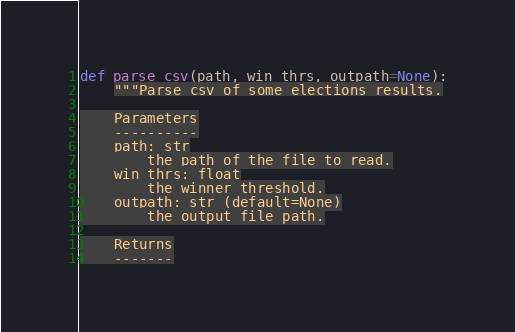<code> <loc_0><loc_0><loc_500><loc_500><_Python_>def parse_csv(path, win_thrs, outpath=None):
    """Parse csv of some elections results.

    Parameters
    ----------
    path: str
        the path of the file to read.
    win_thrs: float
        the winner threshold.
    outpath: str (default=None)
        the output file path.

    Returns
    -------</code> 